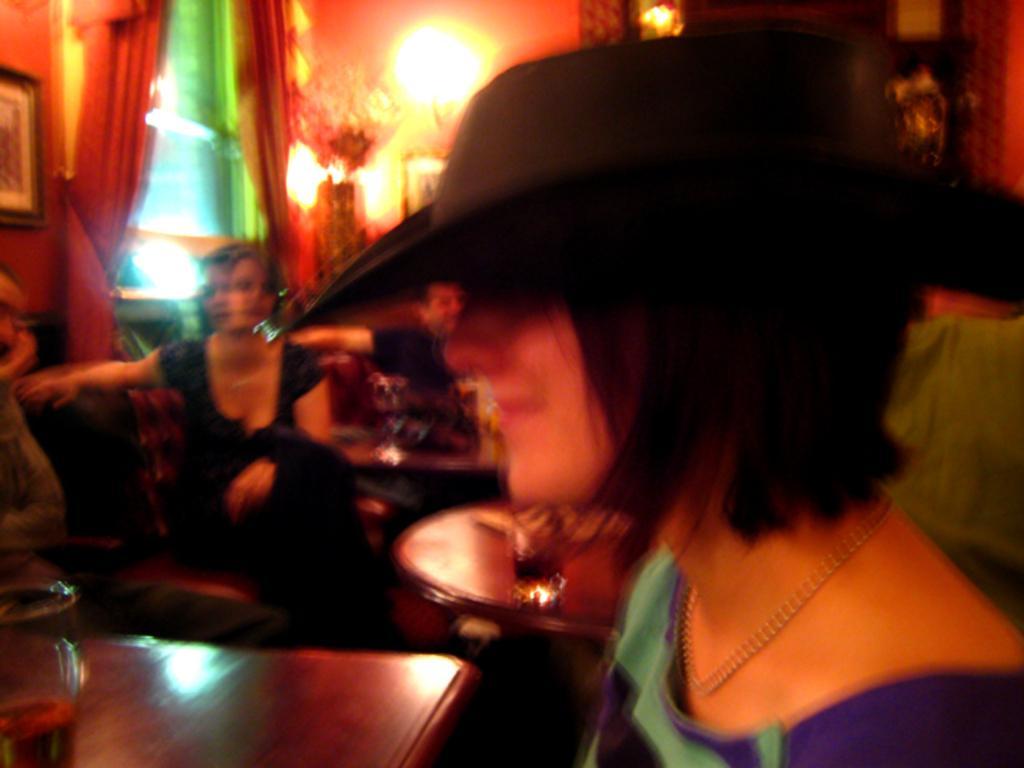Please provide a concise description of this image. In front of the image there is a person wearing a hat, in front of the person there is a glass on the table, beside the person there are a few people sitting on the couches, in front of them there are some glasses and other objects on the tables, behind them on the walls there are photo frames, glass windows, curtains and lamps. 